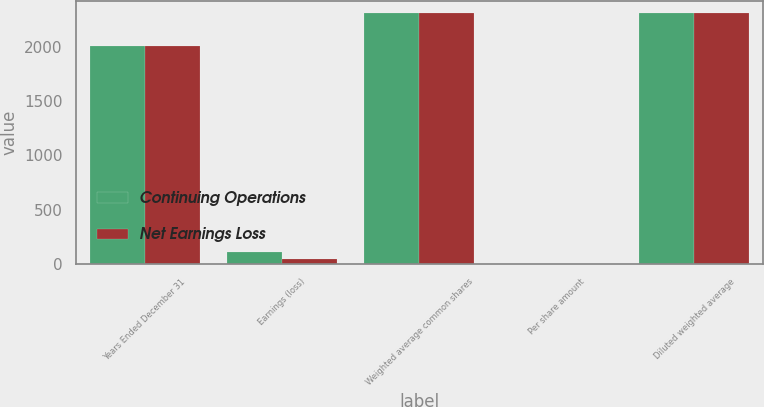Convert chart to OTSL. <chart><loc_0><loc_0><loc_500><loc_500><stacked_bar_chart><ecel><fcel>Years Ended December 31<fcel>Earnings (loss)<fcel>Weighted average common shares<fcel>Per share amount<fcel>Diluted weighted average<nl><fcel>Continuing Operations<fcel>2007<fcel>105<fcel>2312.7<fcel>0.05<fcel>2312.7<nl><fcel>Net Earnings Loss<fcel>2007<fcel>49<fcel>2312.7<fcel>0.02<fcel>2312.7<nl></chart> 